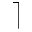<formula> <loc_0><loc_0><loc_500><loc_500>\rceil</formula> 